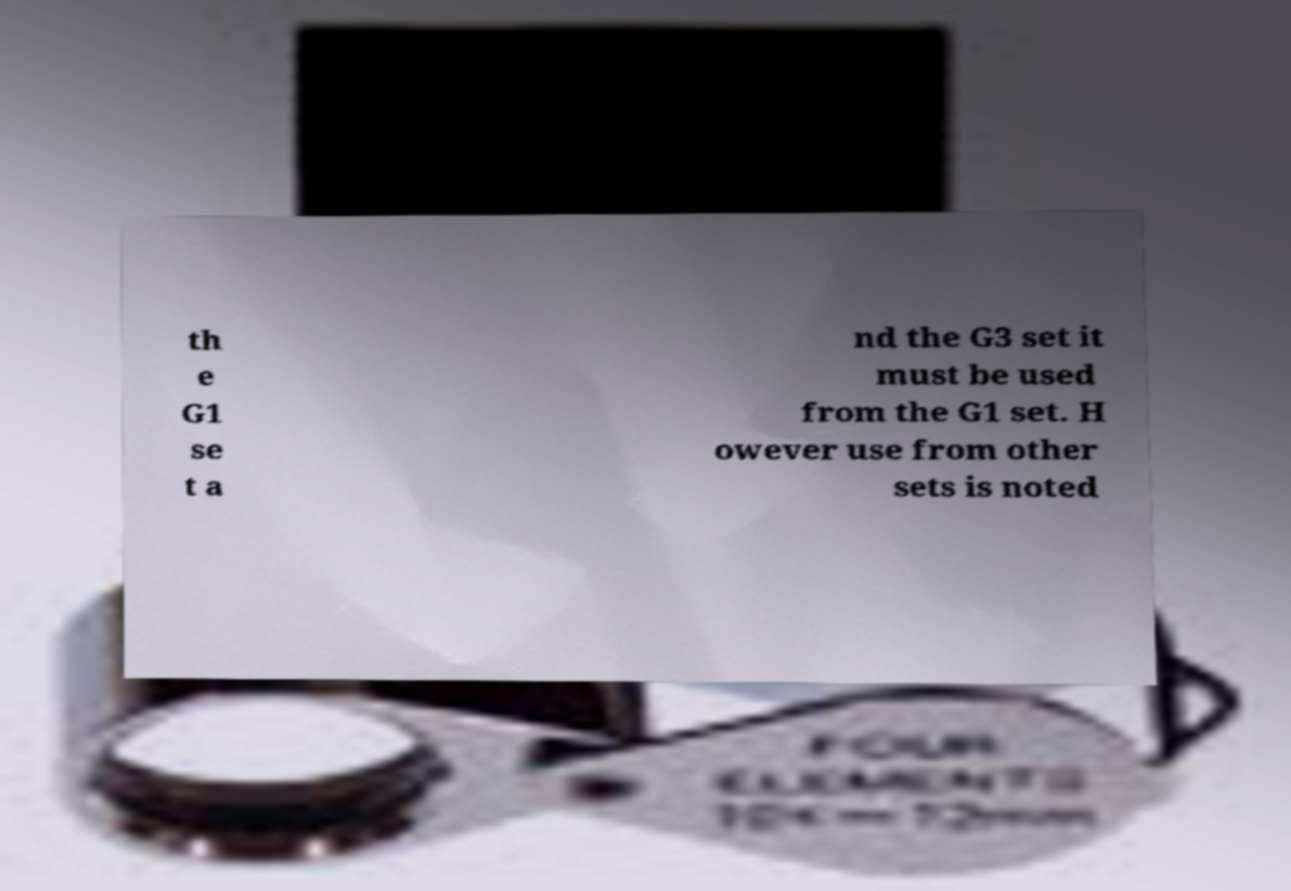I need the written content from this picture converted into text. Can you do that? th e G1 se t a nd the G3 set it must be used from the G1 set. H owever use from other sets is noted 